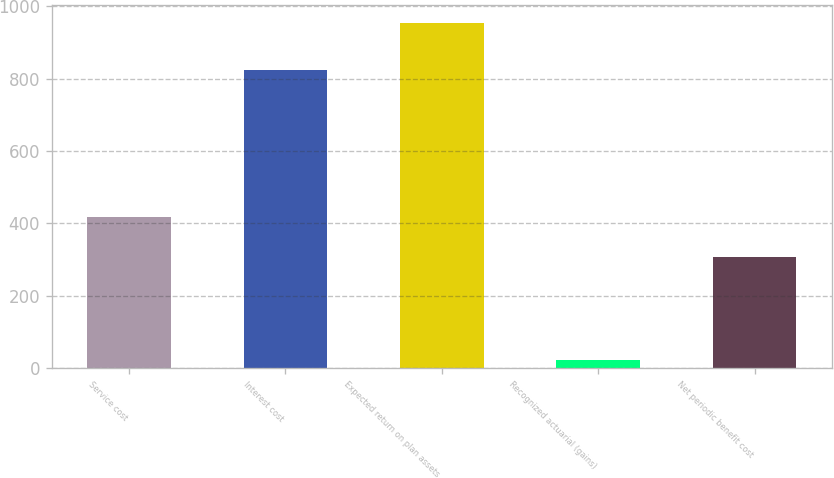Convert chart. <chart><loc_0><loc_0><loc_500><loc_500><bar_chart><fcel>Service cost<fcel>Interest cost<fcel>Expected return on plan assets<fcel>Recognized actuarial (gains)<fcel>Net periodic benefit cost<nl><fcel>417<fcel>823<fcel>955<fcel>23<fcel>308<nl></chart> 